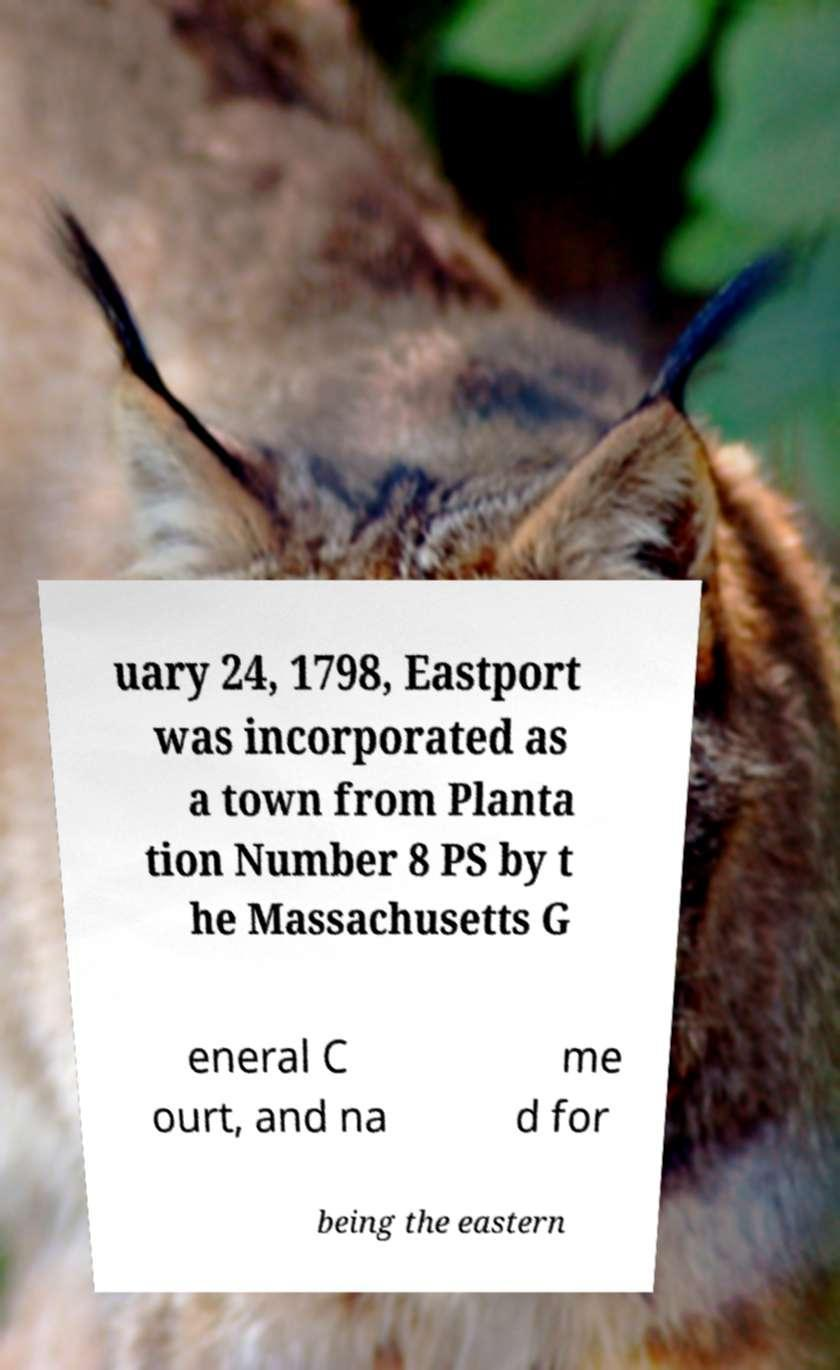Could you extract and type out the text from this image? uary 24, 1798, Eastport was incorporated as a town from Planta tion Number 8 PS by t he Massachusetts G eneral C ourt, and na me d for being the eastern 